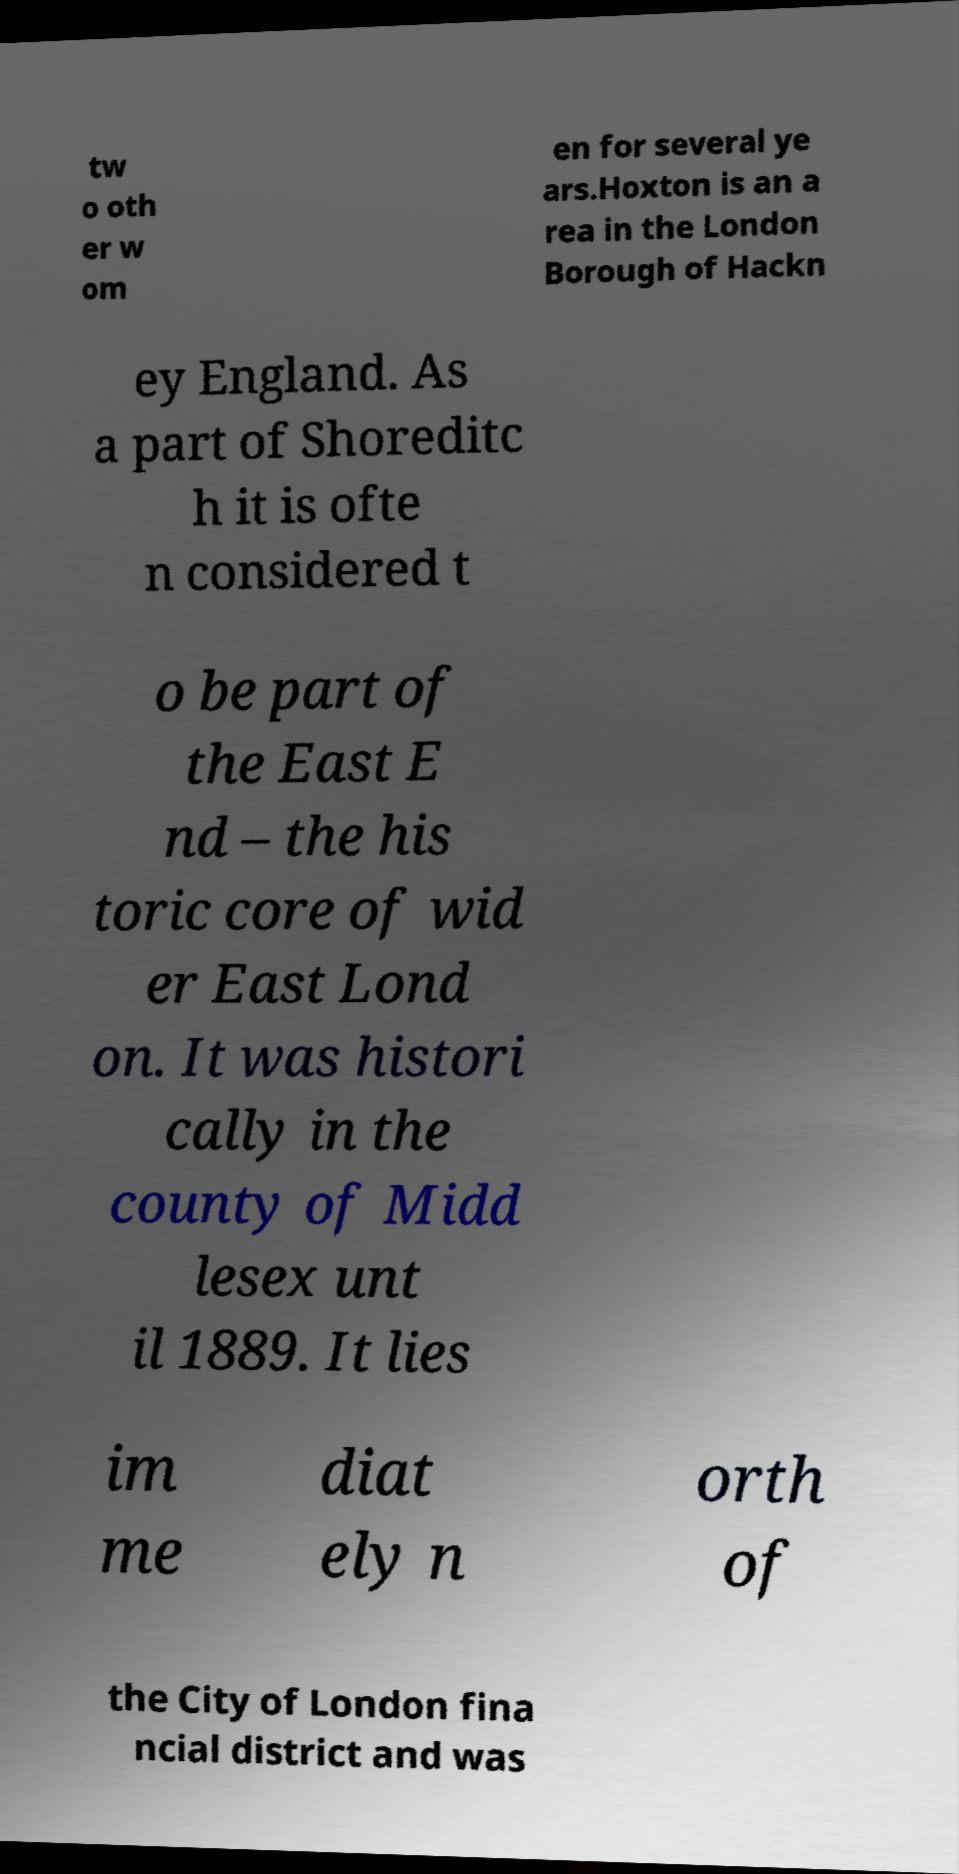Can you read and provide the text displayed in the image?This photo seems to have some interesting text. Can you extract and type it out for me? tw o oth er w om en for several ye ars.Hoxton is an a rea in the London Borough of Hackn ey England. As a part of Shoreditc h it is ofte n considered t o be part of the East E nd – the his toric core of wid er East Lond on. It was histori cally in the county of Midd lesex unt il 1889. It lies im me diat ely n orth of the City of London fina ncial district and was 